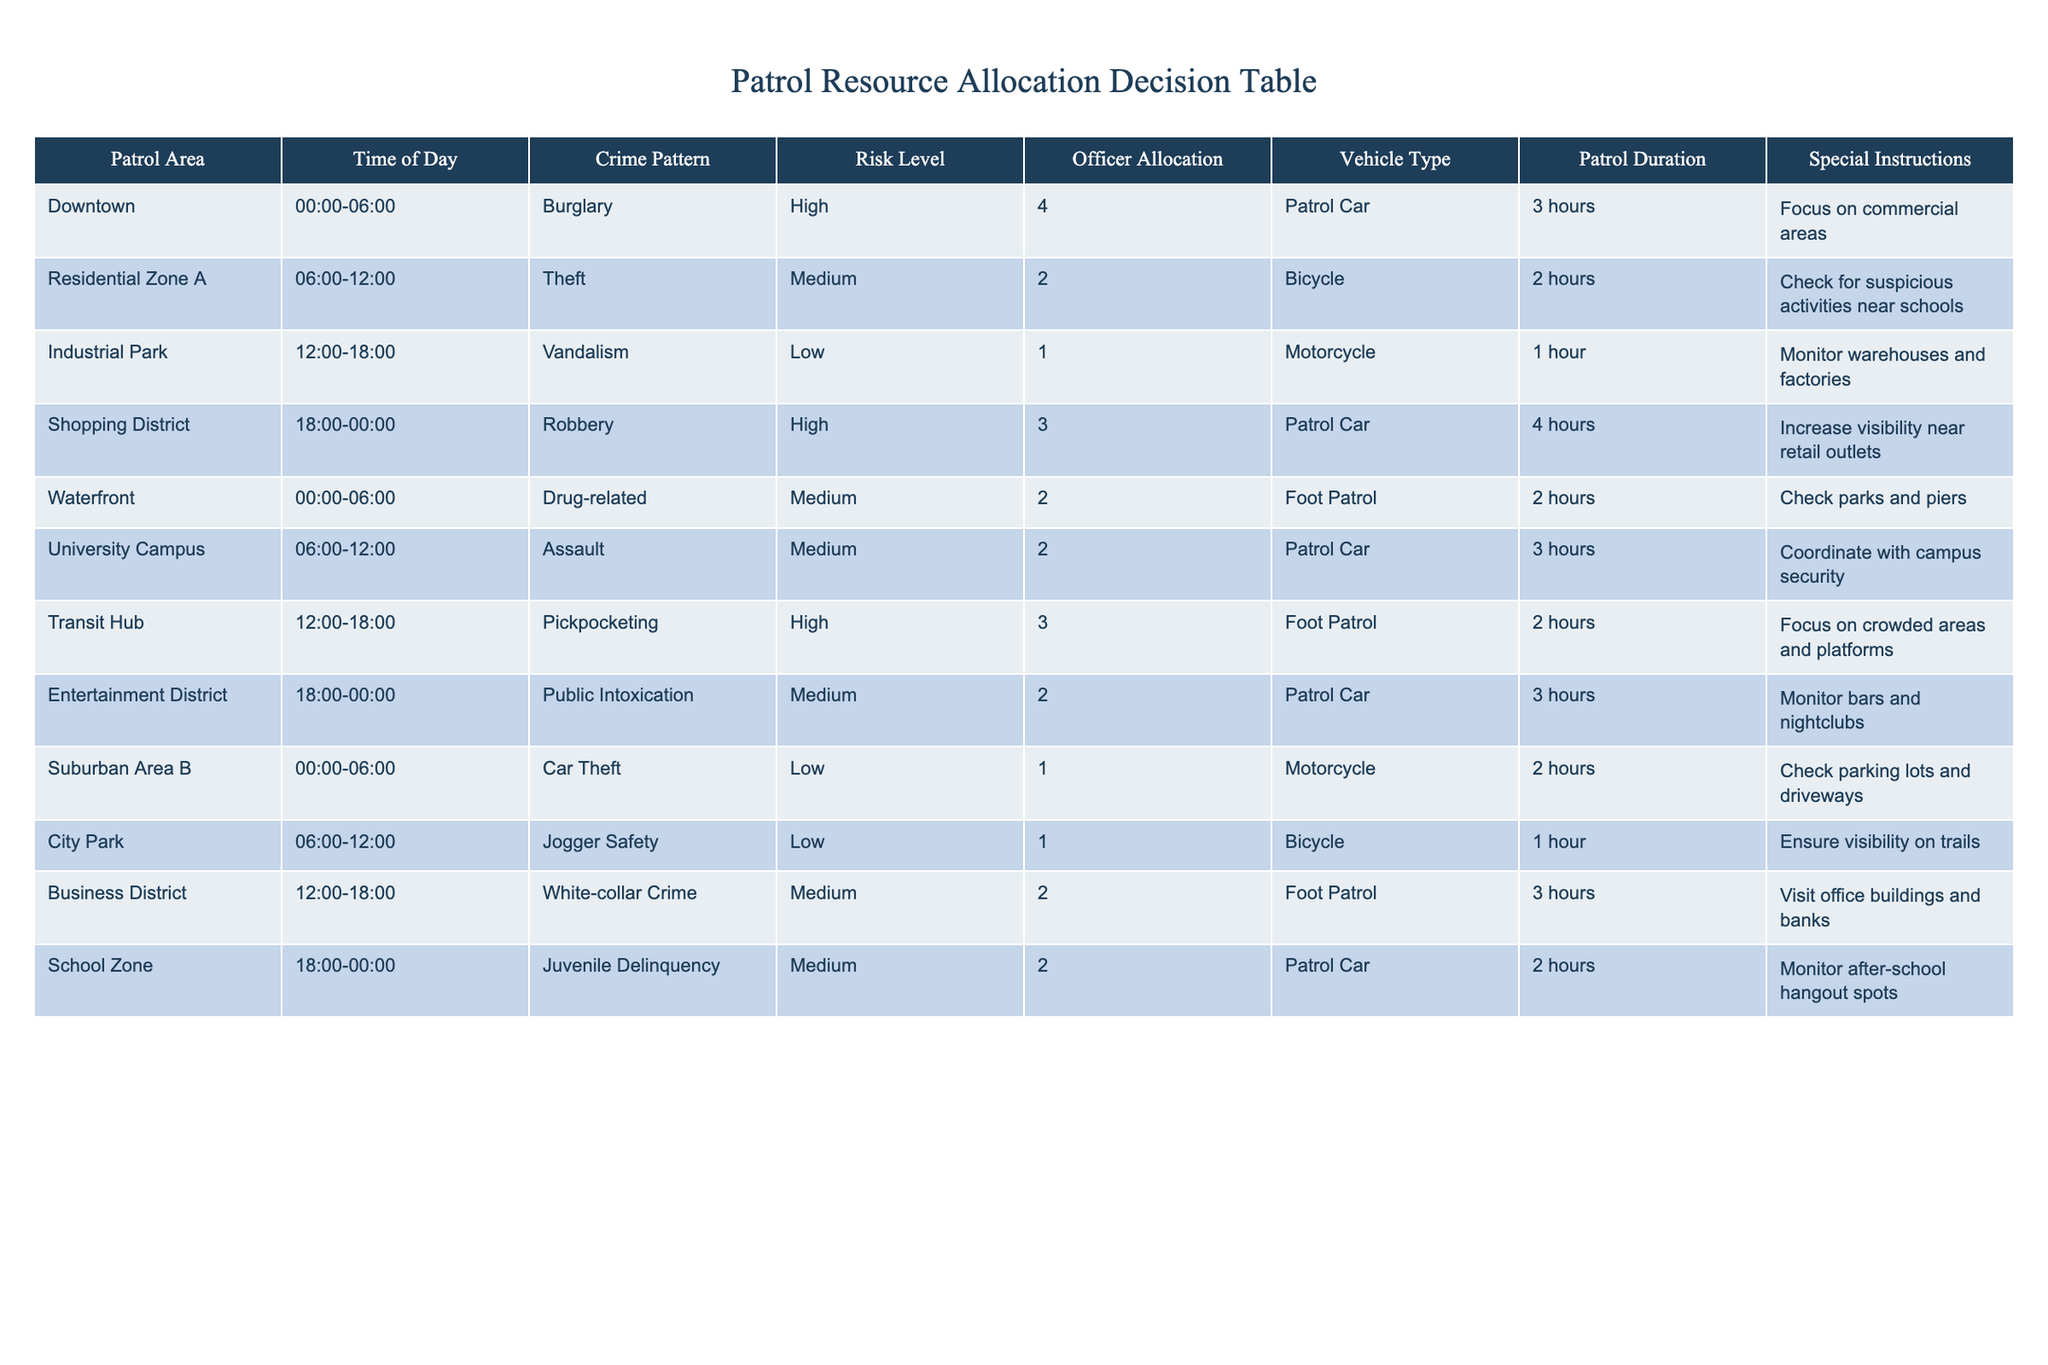What is the total officer allocation for the Downtown area during the night shift? The table indicates that the officer allocation for Downtown during the 00:00-06:00 shift is 4 officers. There's only one row for this area and time, so the total allocation is simply the value given.
Answer: 4 What type of vehicle is assigned to the University Campus during the daytime? The table specifies that the vehicle type assigned to the University Campus during the 06:00-12:00 shift is a Patrol Car. This information is directly visible in the corresponding row.
Answer: Patrol Car How many hours of patrol duration are allocated for the Shopping District? The Shopping District operates between 18:00-00:00, and the table lists a patrol duration of 4 hours for this area. This value is taken directly from the relevant row in the table.
Answer: 4 hours Is there a specific instruction for officers patrolling the Waterfront? Yes, the special instruction for the Waterfront is to check parks and piers. This information is provided in the corresponding row of the table.
Answer: Yes What is the average officer allocation for areas with a "High" risk level? To calculate the average, we need to identify all rows with a risk level of "High." These are Downtown and Transit Hub, with allocations of 4 and 3 officers respectively. The total is 4 + 3 = 7. There are 2 data points, so the average is 7/2 = 3.5.
Answer: 3.5 What is the patrol duration in the Residential Zone A compared to the patrol duration in Suburban Area B? The Residential Zone A has a patrol duration of 2 hours while Suburban Area B also has a patrol duration of 2 hours. Since both durations are the same, we conclude that they are equal.
Answer: Both are equal (2 hours) In what time slot does the Industrial Park have the lowest crime pattern? The table indicates that the Industrial Park operates from 12:00-18:00 and reports a vandalism pattern classified as "Low." This is the only entry we need to refer to, confirming that it indeed has the lowest crime pattern in the specified timeframe.
Answer: 12:00-18:00 Which areas are assigned foot patrols, and during what times? The table lists two areas with foot patrols: the Waterfront (00:00-06:00) and the Transit Hub (12:00-18:00). To get this answer, we simply look for rows in the table where the vehicle type is "Foot Patrol."
Answer: Waterfront (00:00-06:00), Transit Hub (12:00-18:00) How does the crime pattern change from the Downtown area to the Residential Zone A? The Downtown area has a crime pattern of "Burglary," which is classified as "High" risk, while the Residential Zone A has a crime pattern of "Theft," categorized as "Medium" risk. We compare the criminal activities listed in the respective rows to arrive at this conclusion.
Answer: Changes from High (Burglary) to Medium (Theft) 